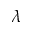<formula> <loc_0><loc_0><loc_500><loc_500>\lambda</formula> 